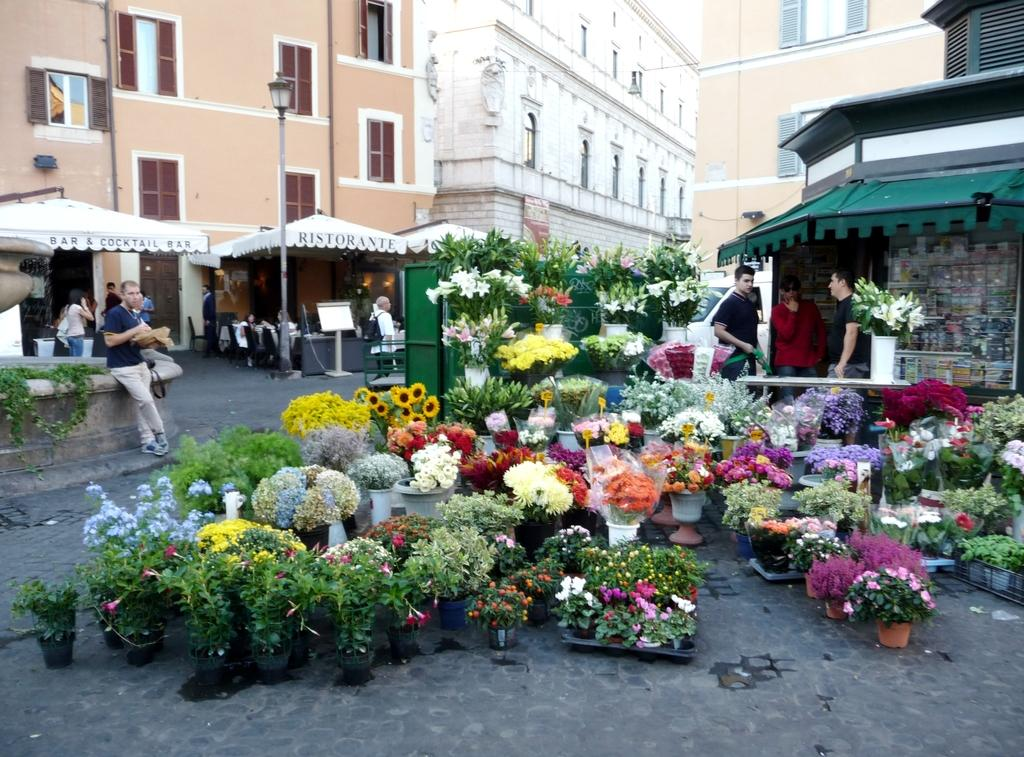What type of structures can be seen in the image? There are buildings in the image. What architectural feature can be seen on the buildings? There are windows in the image. What is the tall, vertical object in the image? There is a light pole in the image. What type of temporary shelter is present in the image? There are tents in the image. What type of plants can be seen in the image? There are colorful flowers in the image. What type of containers are present for the flowers? There are flower pots in the image. What mode of transportation is visible in the image? There is a vehicle in the image. What type of seating is present in the image? There are people sitting on chairs in the image. What type of standing position can be seen in the image? There are people standing in the image. What type of cheese is being served on the notebook in the image? There is no cheese or notebook present in the image. What is the title of the book that the people are reading in the image? There is no book or reading activity depicted in the image. 